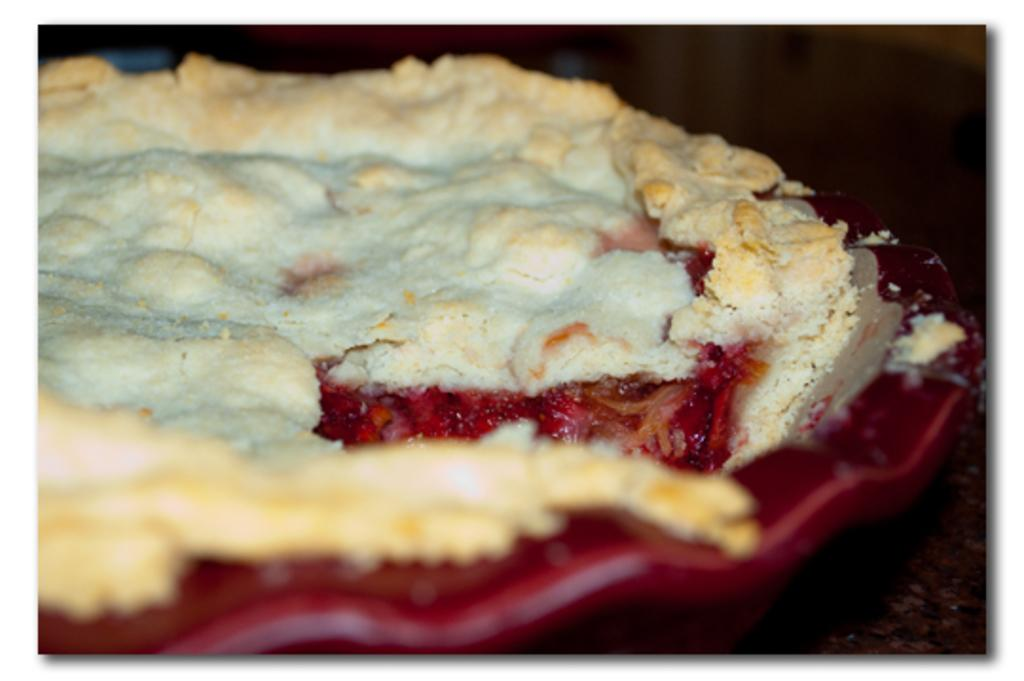What is the main object in the center of the image? There is a red color palette in the center of the image. What can be found on the palette? The palette contains some food items. What else can be seen in the image besides the palette? There are other objects visible in the background of the image. How many pigs are present in the image? There are no pigs present in the image. Is there a stranger interacting with the food items on the palette? There is no stranger present in the image. 